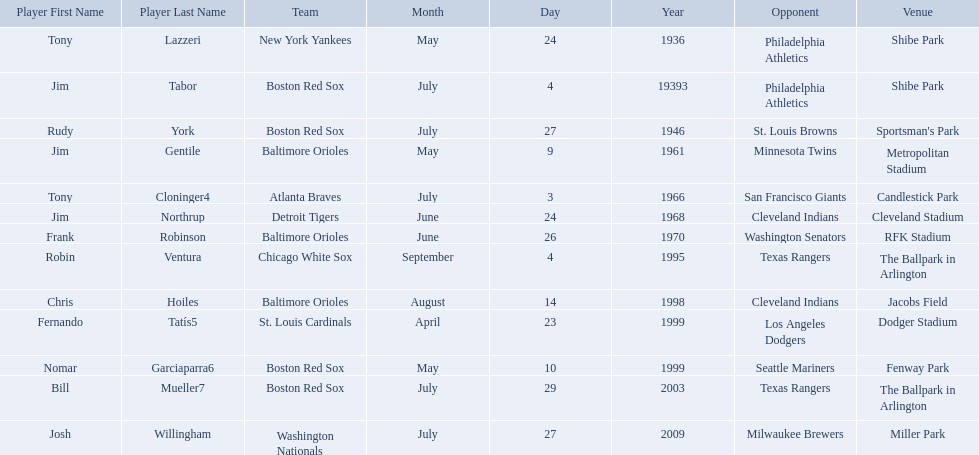Who are the opponents of the boston red sox during baseball home run records? Philadelphia Athletics, St. Louis Browns, Seattle Mariners, Texas Rangers. Of those which was the opponent on july 27, 1946? St. Louis Browns. Who were all of the players? Tony Lazzeri, Jim Tabor, Rudy York, Jim Gentile, Tony Cloninger4, Jim Northrup, Frank Robinson, Robin Ventura, Chris Hoiles, Fernando Tatís5, Nomar Garciaparra6, Bill Mueller7, Josh Willingham. Could you help me parse every detail presented in this table? {'header': ['Player First Name', 'Player Last Name', 'Team', 'Month', 'Day', 'Year', 'Opponent', 'Venue'], 'rows': [['Tony', 'Lazzeri', 'New York Yankees', 'May', '24', '1936', 'Philadelphia Athletics', 'Shibe Park'], ['Jim', 'Tabor', 'Boston Red Sox', 'July', '4', '19393', 'Philadelphia Athletics', 'Shibe Park'], ['Rudy', 'York', 'Boston Red Sox', 'July', '27', '1946', 'St. Louis Browns', "Sportsman's Park"], ['Jim', 'Gentile', 'Baltimore Orioles', 'May', '9', '1961', 'Minnesota Twins', 'Metropolitan Stadium'], ['Tony', 'Cloninger4', 'Atlanta Braves', 'July', '3', '1966', 'San Francisco Giants', 'Candlestick Park'], ['Jim', 'Northrup', 'Detroit Tigers', 'June', '24', '1968', 'Cleveland Indians', 'Cleveland Stadium'], ['Frank', 'Robinson', 'Baltimore Orioles', 'June', '26', '1970', 'Washington Senators', 'RFK Stadium'], ['Robin', 'Ventura', 'Chicago White Sox', 'September', '4', '1995', 'Texas Rangers', 'The Ballpark in Arlington'], ['Chris', 'Hoiles', 'Baltimore Orioles', 'August', '14', '1998', 'Cleveland Indians', 'Jacobs Field'], ['Fernando', 'Tatís5', 'St. Louis Cardinals', 'April', '23', '1999', 'Los Angeles Dodgers', 'Dodger Stadium'], ['Nomar', 'Garciaparra6', 'Boston Red Sox', 'May', '10', '1999', 'Seattle Mariners', 'Fenway Park'], ['Bill', 'Mueller7', 'Boston Red Sox', 'July', '29', '2003', 'Texas Rangers', 'The Ballpark in Arlington'], ['Josh', 'Willingham', 'Washington Nationals', 'July', '27', '2009', 'Milwaukee Brewers', 'Miller Park']]} What year was there a player for the yankees? May 24, 1936. What was the name of that 1936 yankees player? Tony Lazzeri. 